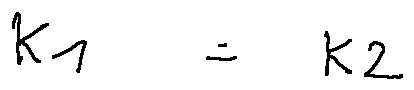Convert formula to latex. <formula><loc_0><loc_0><loc_500><loc_500>k _ { 1 } = k _ { 2 }</formula> 